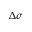Convert formula to latex. <formula><loc_0><loc_0><loc_500><loc_500>\Delta \sigma</formula> 